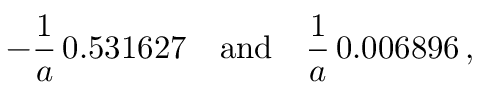Convert formula to latex. <formula><loc_0><loc_0><loc_500><loc_500>- \frac { 1 } { a } \, 0 . 5 3 1 6 2 7 \quad a n d \quad \frac { 1 } { a } \, 0 . 0 0 6 8 9 6 \, { , }</formula> 